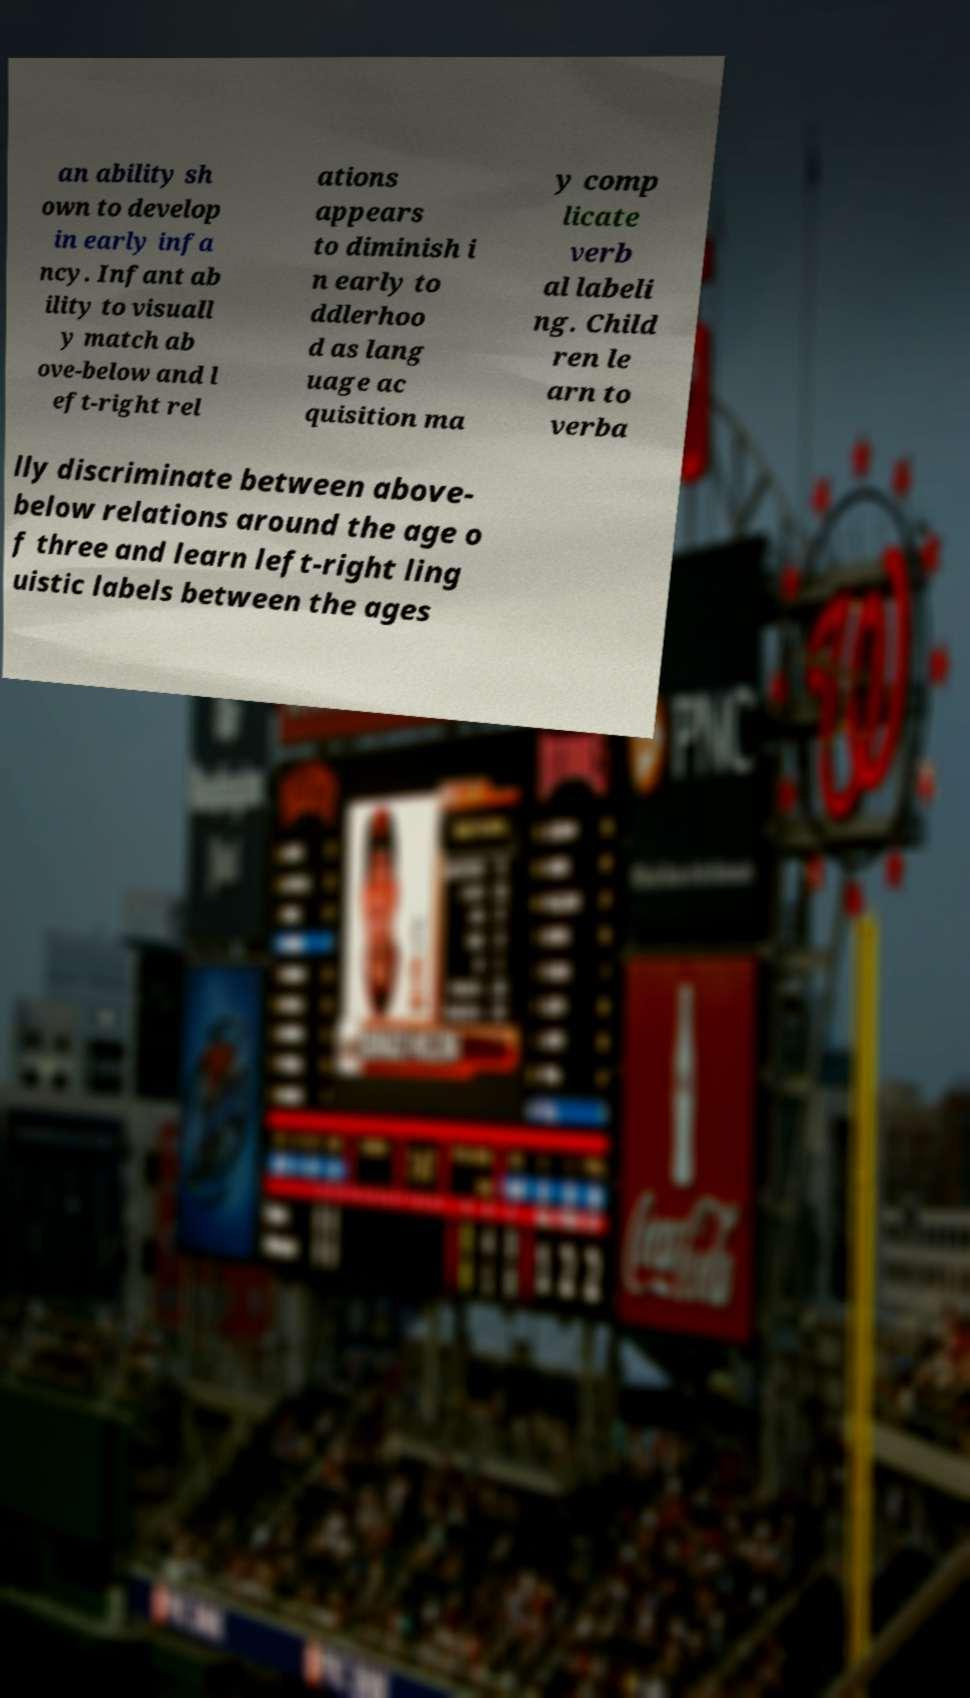For documentation purposes, I need the text within this image transcribed. Could you provide that? an ability sh own to develop in early infa ncy. Infant ab ility to visuall y match ab ove-below and l eft-right rel ations appears to diminish i n early to ddlerhoo d as lang uage ac quisition ma y comp licate verb al labeli ng. Child ren le arn to verba lly discriminate between above- below relations around the age o f three and learn left-right ling uistic labels between the ages 